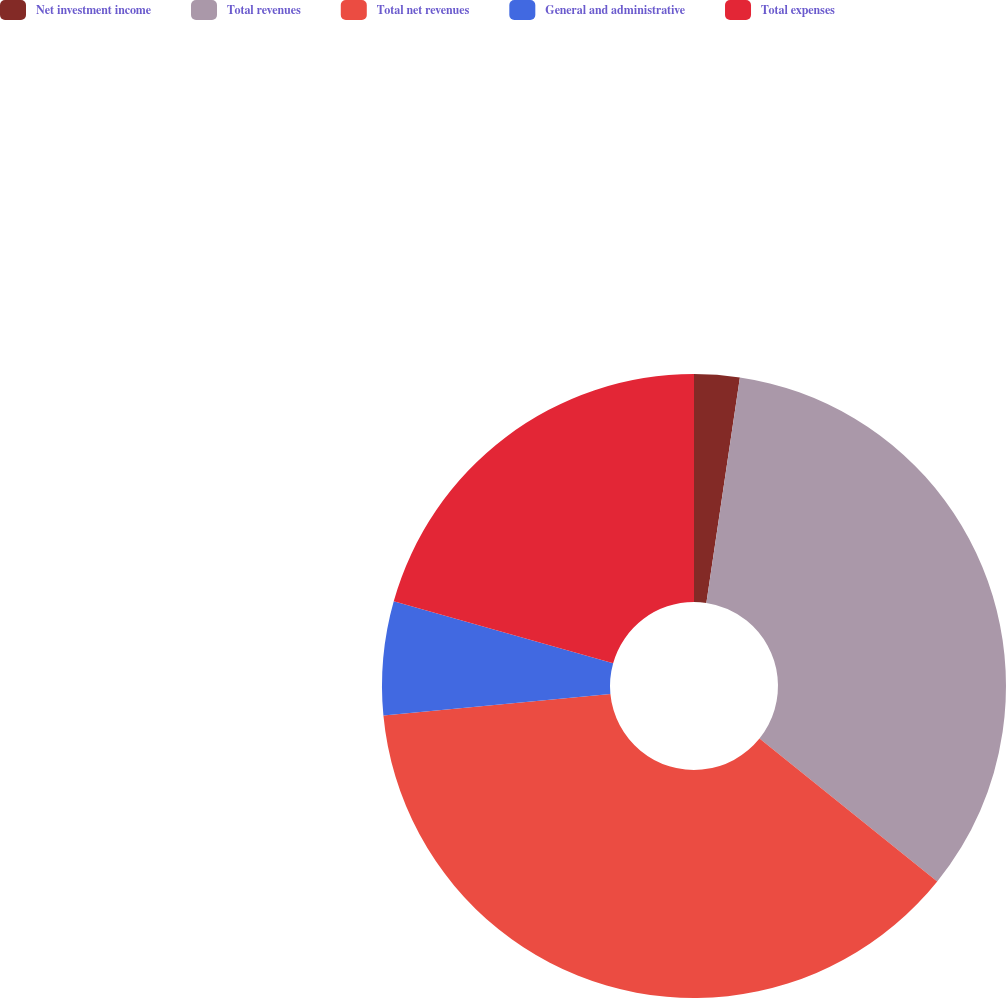Convert chart. <chart><loc_0><loc_0><loc_500><loc_500><pie_chart><fcel>Net investment income<fcel>Total revenues<fcel>Total net revenues<fcel>General and administrative<fcel>Total expenses<nl><fcel>2.35%<fcel>33.42%<fcel>37.72%<fcel>5.89%<fcel>20.62%<nl></chart> 